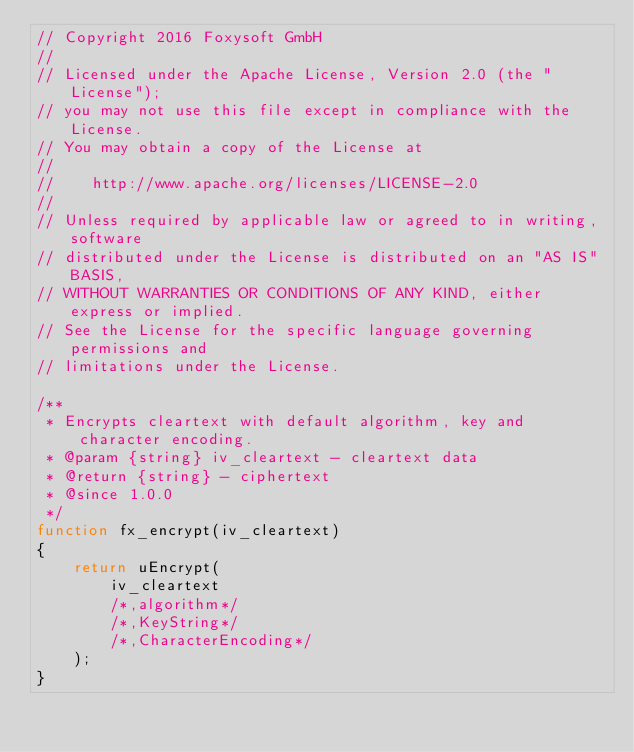Convert code to text. <code><loc_0><loc_0><loc_500><loc_500><_JavaScript_>// Copyright 2016 Foxysoft GmbH
// 
// Licensed under the Apache License, Version 2.0 (the "License");
// you may not use this file except in compliance with the License.
// You may obtain a copy of the License at
//
//    http://www.apache.org/licenses/LICENSE-2.0
//
// Unless required by applicable law or agreed to in writing, software
// distributed under the License is distributed on an "AS IS" BASIS,
// WITHOUT WARRANTIES OR CONDITIONS OF ANY KIND, either express or implied.
// See the License for the specific language governing permissions and
// limitations under the License.

/**
 * Encrypts cleartext with default algorithm, key and character encoding.
 * @param {string} iv_cleartext - cleartext data
 * @return {string} - ciphertext
 * @since 1.0.0
 */
function fx_encrypt(iv_cleartext)
{
    return uEncrypt(
        iv_cleartext
        /*,algorithm*/
        /*,KeyString*/
        /*,CharacterEncoding*/
    );
}
</code> 